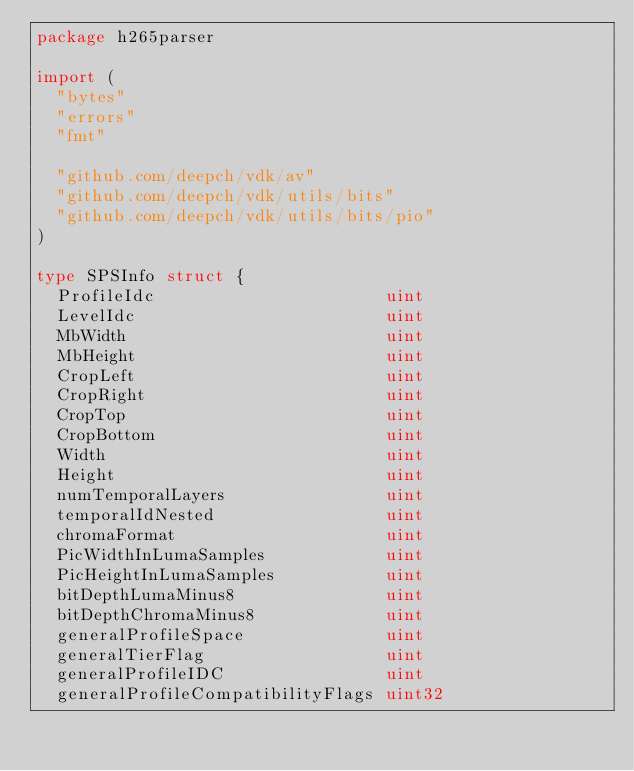Convert code to text. <code><loc_0><loc_0><loc_500><loc_500><_Go_>package h265parser

import (
	"bytes"
	"errors"
	"fmt"

	"github.com/deepch/vdk/av"
	"github.com/deepch/vdk/utils/bits"
	"github.com/deepch/vdk/utils/bits/pio"
)

type SPSInfo struct {
	ProfileIdc                       uint
	LevelIdc                         uint
	MbWidth                          uint
	MbHeight                         uint
	CropLeft                         uint
	CropRight                        uint
	CropTop                          uint
	CropBottom                       uint
	Width                            uint
	Height                           uint
	numTemporalLayers                uint
	temporalIdNested                 uint
	chromaFormat                     uint
	PicWidthInLumaSamples            uint
	PicHeightInLumaSamples           uint
	bitDepthLumaMinus8               uint
	bitDepthChromaMinus8             uint
	generalProfileSpace              uint
	generalTierFlag                  uint
	generalProfileIDC                uint
	generalProfileCompatibilityFlags uint32</code> 